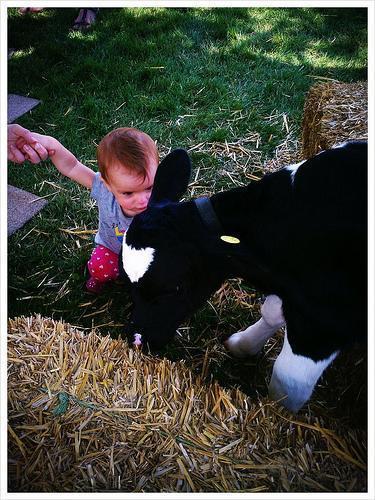How many calves are there?
Give a very brief answer. 1. 